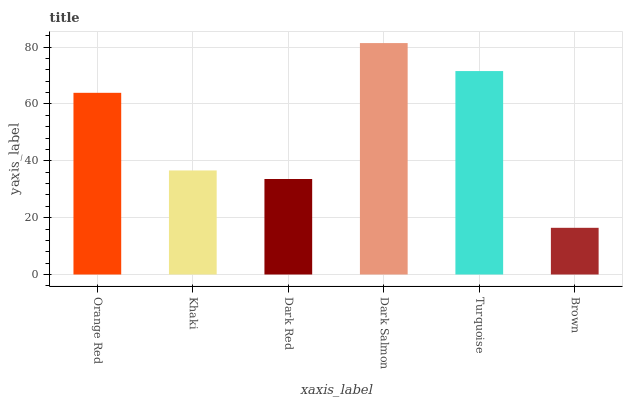Is Brown the minimum?
Answer yes or no. Yes. Is Dark Salmon the maximum?
Answer yes or no. Yes. Is Khaki the minimum?
Answer yes or no. No. Is Khaki the maximum?
Answer yes or no. No. Is Orange Red greater than Khaki?
Answer yes or no. Yes. Is Khaki less than Orange Red?
Answer yes or no. Yes. Is Khaki greater than Orange Red?
Answer yes or no. No. Is Orange Red less than Khaki?
Answer yes or no. No. Is Orange Red the high median?
Answer yes or no. Yes. Is Khaki the low median?
Answer yes or no. Yes. Is Khaki the high median?
Answer yes or no. No. Is Brown the low median?
Answer yes or no. No. 